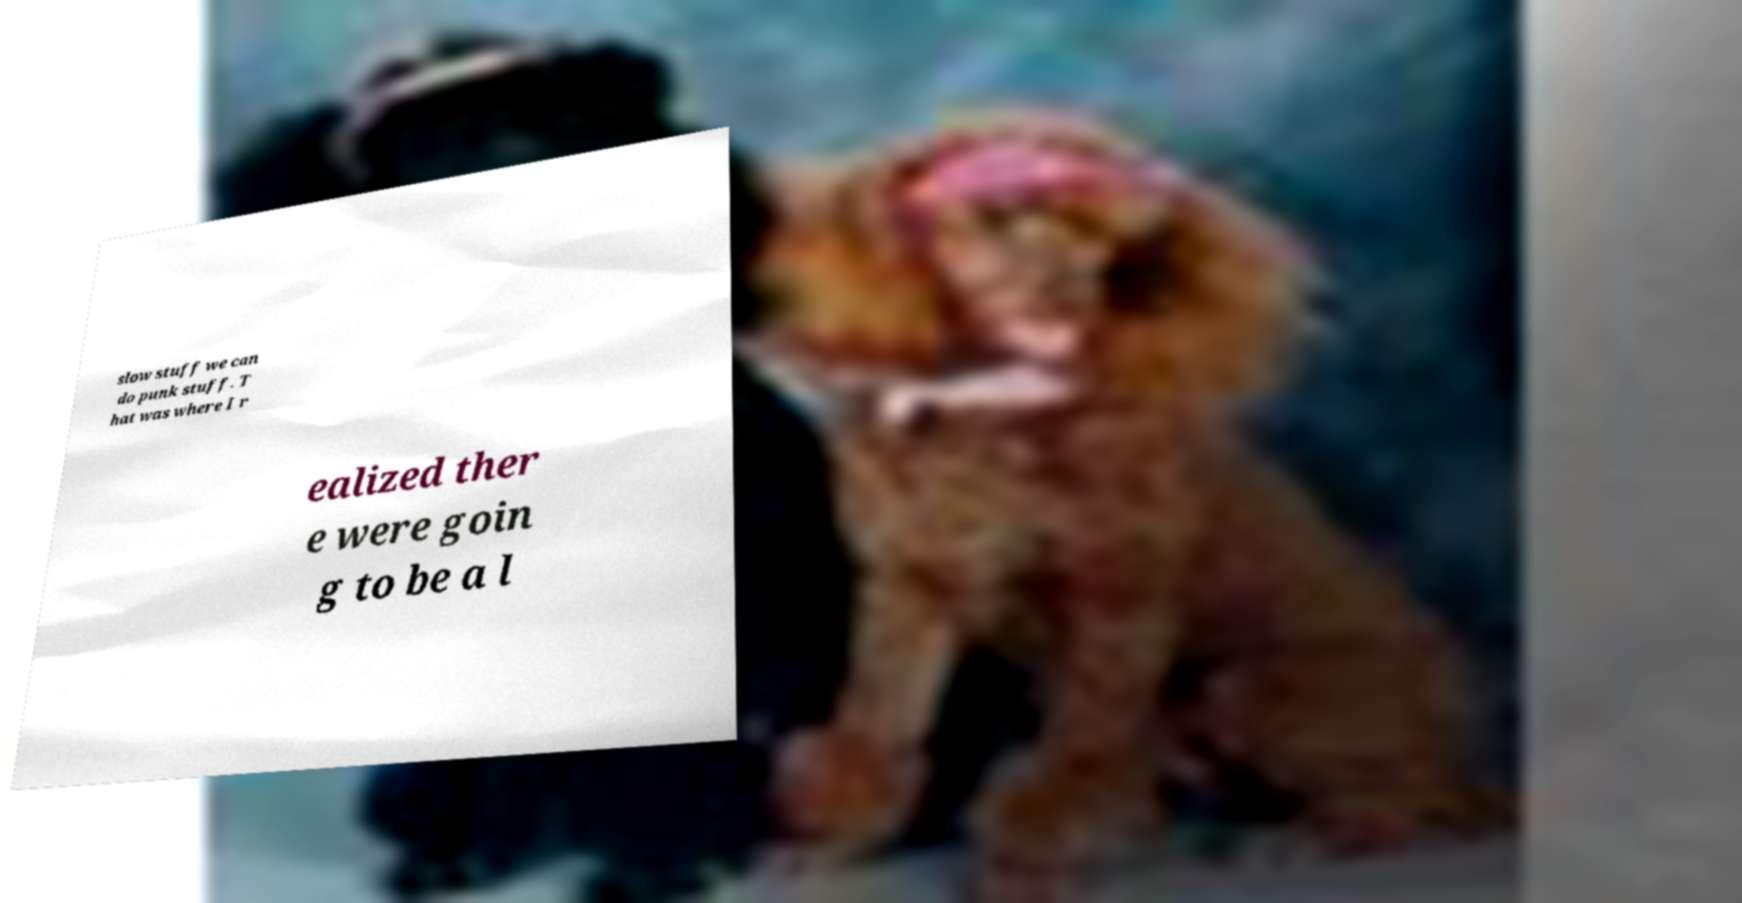There's text embedded in this image that I need extracted. Can you transcribe it verbatim? slow stuff we can do punk stuff. T hat was where I r ealized ther e were goin g to be a l 